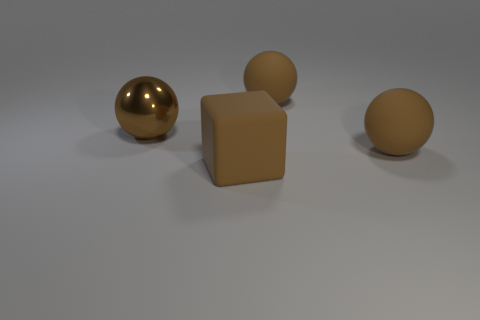How many other things are the same color as the big metallic thing?
Keep it short and to the point. 3. Are there fewer blocks that are left of the big brown block than large brown shiny objects right of the big metal ball?
Your answer should be compact. No. What number of things are brown balls that are right of the block or brown shiny balls?
Ensure brevity in your answer.  3. There is a brown matte cube; is it the same size as the rubber sphere that is behind the large shiny sphere?
Offer a terse response. Yes. What number of big rubber cubes are behind the brown rubber object in front of the ball in front of the big brown shiny ball?
Give a very brief answer. 0. What number of balls are either big shiny things or large brown things?
Your answer should be compact. 3. The large metallic sphere that is in front of the large matte object that is behind the large brown shiny object behind the big brown matte block is what color?
Provide a short and direct response. Brown. How many other things are the same size as the shiny sphere?
Make the answer very short. 3. Is there any other thing that has the same shape as the big brown metallic object?
Your answer should be very brief. Yes. Are there an equal number of brown metal objects to the right of the brown cube and small rubber things?
Keep it short and to the point. Yes. 